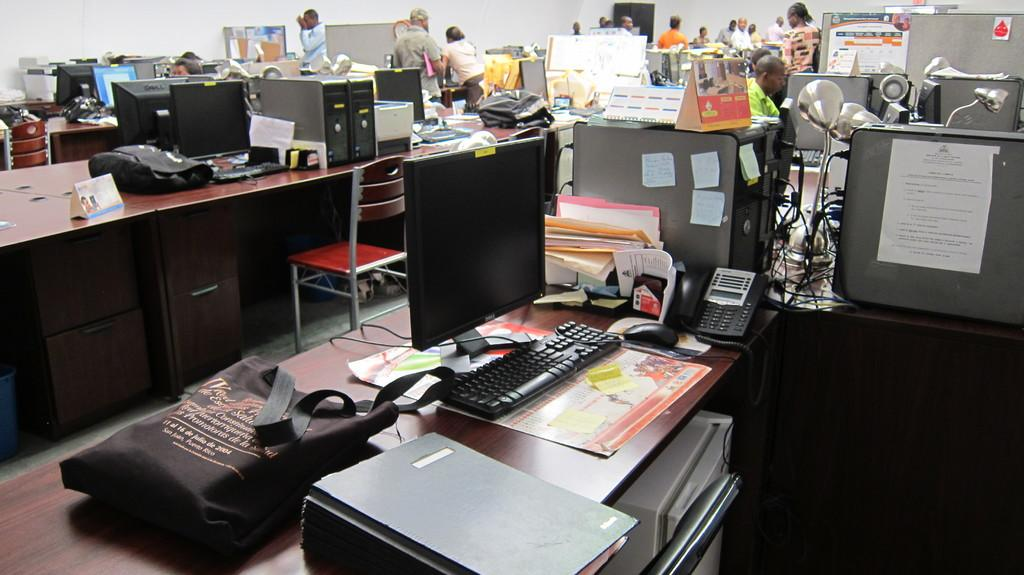What type of electronic device is visible in the image? There is a monitor in the image. What is used for input with the monitor? There is a keyboard and a mouse in the image. What might be used to store or organize information in the image? There is a file in the image. What type of furniture is present in the image? There is a table and a chair in the image. What type of lighting is present in the image? There are lights in the image. Who might be using the computer setup in the image? There are persons in the image. What type of reminders or notes might be present in the image? There are sticky notes in the image. What type of fabric is present in the image? There is a cloth in the image. What type of bag is present in the image? There is a bag in the image. What type of organizational tool might be present in the image? There are calendars in the image. What type of background is present in the image? There is a wall in the image. How does the sponge help the manager in the image? There is no sponge present in the image, and therefore it cannot help the manager. 